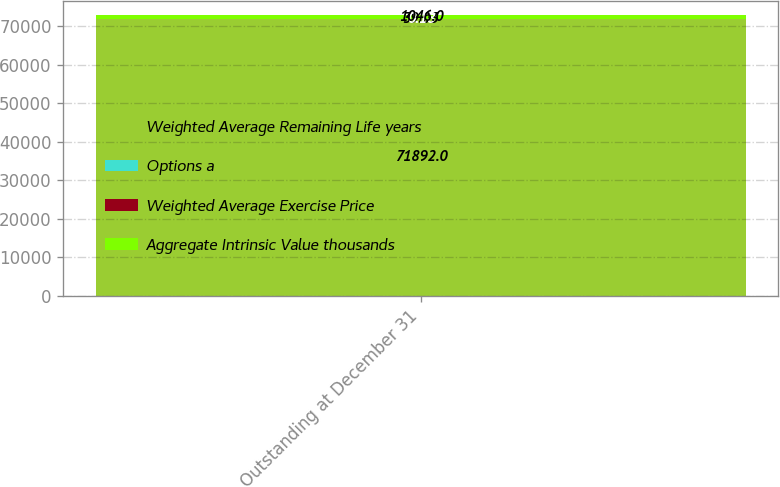<chart> <loc_0><loc_0><loc_500><loc_500><stacked_bar_chart><ecel><fcel>Outstanding at December 31<nl><fcel>Weighted Average Remaining Life years<fcel>71892<nl><fcel>Options a<fcel>39.03<nl><fcel>Weighted Average Exercise Price<fcel>0.18<nl><fcel>Aggregate Intrinsic Value thousands<fcel>1046<nl></chart> 